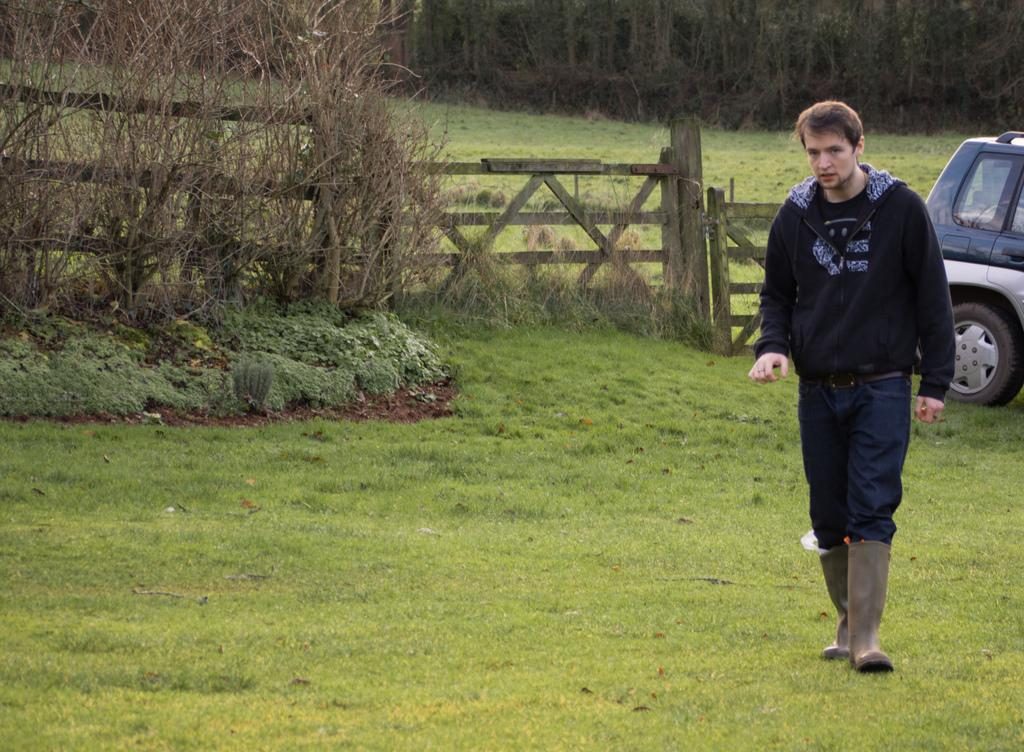What is present in the image along with the person? There is a vehicle in the image. What is the ground covered with? The ground is covered with grass. What other types of vegetation can be seen in the image? There are plants and trees in the image. Are there any specific types of trees in the image? Yes, there are some dried trees in the image. What type of jelly is being used to fix the crime scene in the image? There is no jelly or crime scene present in the image. What color is the patch on the person's clothing in the image? There is no mention of a patch on the person's clothing in the image. 